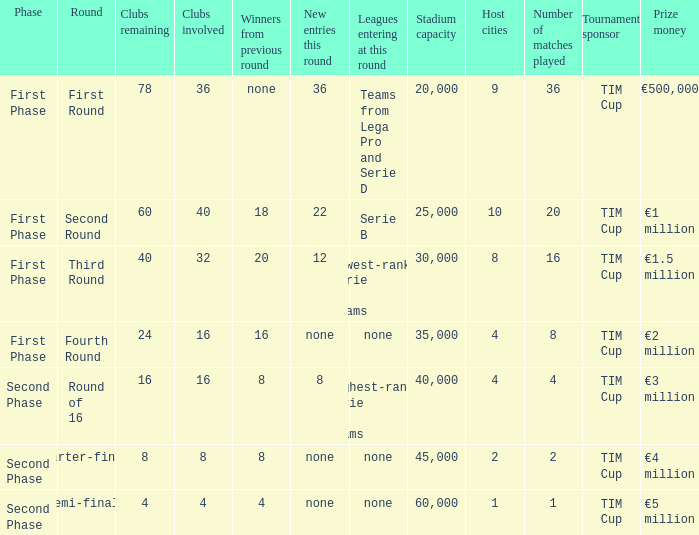During the first phase portion of phase and having 16 clubs involved; what would you find for the winners from previous round? 16.0. 